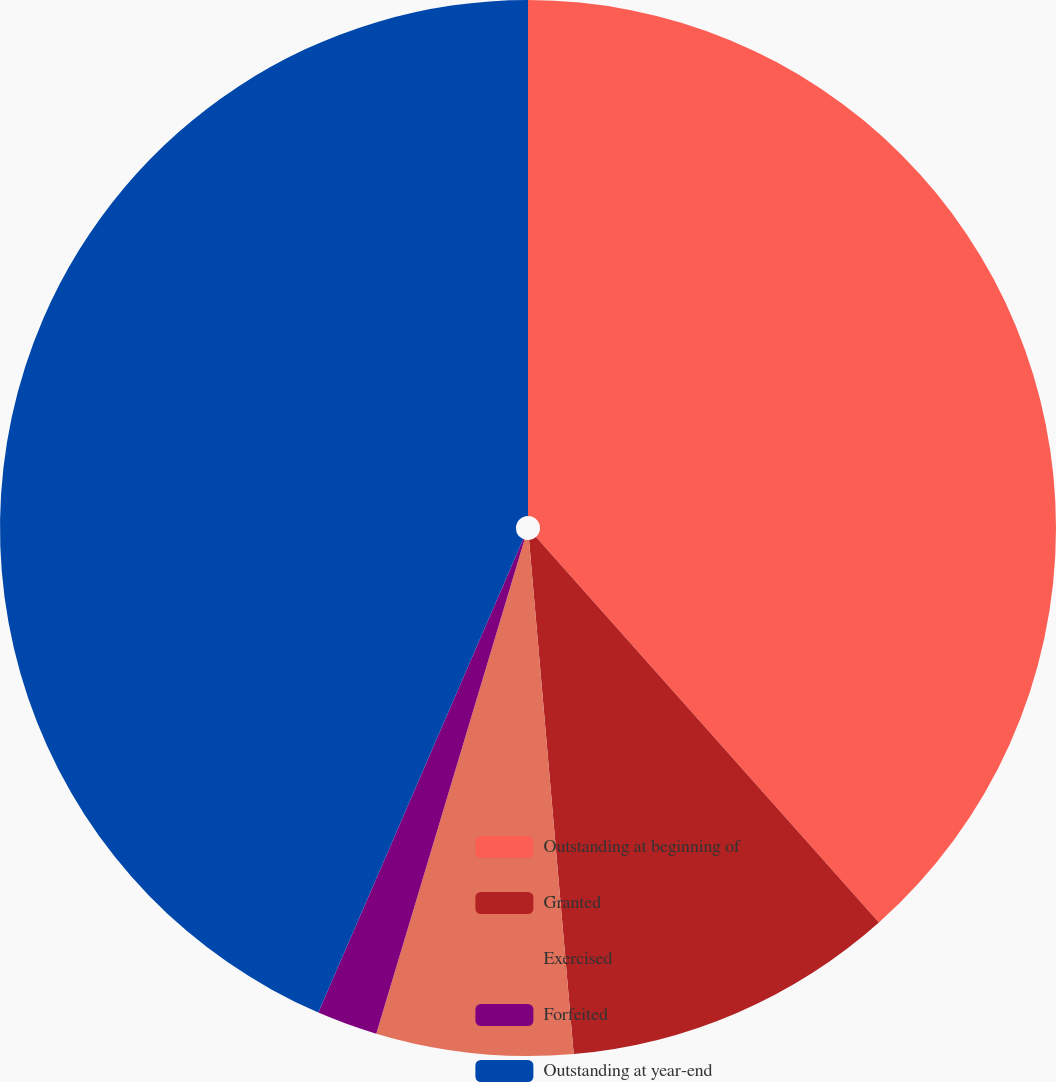<chart> <loc_0><loc_0><loc_500><loc_500><pie_chart><fcel>Outstanding at beginning of<fcel>Granted<fcel>Exercised<fcel>Forfeited<fcel>Outstanding at year-end<nl><fcel>38.43%<fcel>10.19%<fcel>6.02%<fcel>1.86%<fcel>43.5%<nl></chart> 